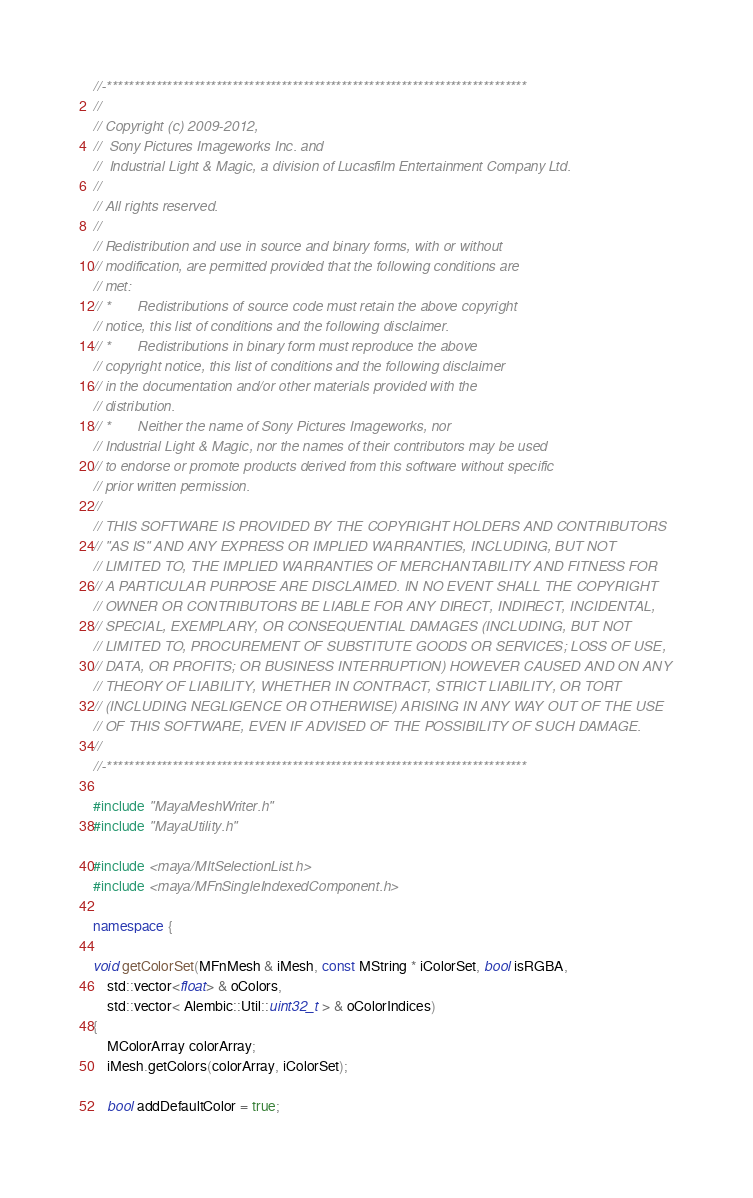Convert code to text. <code><loc_0><loc_0><loc_500><loc_500><_C++_>//-*****************************************************************************
//
// Copyright (c) 2009-2012,
//  Sony Pictures Imageworks Inc. and
//  Industrial Light & Magic, a division of Lucasfilm Entertainment Company Ltd.
//
// All rights reserved.
//
// Redistribution and use in source and binary forms, with or without
// modification, are permitted provided that the following conditions are
// met:
// *       Redistributions of source code must retain the above copyright
// notice, this list of conditions and the following disclaimer.
// *       Redistributions in binary form must reproduce the above
// copyright notice, this list of conditions and the following disclaimer
// in the documentation and/or other materials provided with the
// distribution.
// *       Neither the name of Sony Pictures Imageworks, nor
// Industrial Light & Magic, nor the names of their contributors may be used
// to endorse or promote products derived from this software without specific
// prior written permission.
//
// THIS SOFTWARE IS PROVIDED BY THE COPYRIGHT HOLDERS AND CONTRIBUTORS
// "AS IS" AND ANY EXPRESS OR IMPLIED WARRANTIES, INCLUDING, BUT NOT
// LIMITED TO, THE IMPLIED WARRANTIES OF MERCHANTABILITY AND FITNESS FOR
// A PARTICULAR PURPOSE ARE DISCLAIMED. IN NO EVENT SHALL THE COPYRIGHT
// OWNER OR CONTRIBUTORS BE LIABLE FOR ANY DIRECT, INDIRECT, INCIDENTAL,
// SPECIAL, EXEMPLARY, OR CONSEQUENTIAL DAMAGES (INCLUDING, BUT NOT
// LIMITED TO, PROCUREMENT OF SUBSTITUTE GOODS OR SERVICES; LOSS OF USE,
// DATA, OR PROFITS; OR BUSINESS INTERRUPTION) HOWEVER CAUSED AND ON ANY
// THEORY OF LIABILITY, WHETHER IN CONTRACT, STRICT LIABILITY, OR TORT
// (INCLUDING NEGLIGENCE OR OTHERWISE) ARISING IN ANY WAY OUT OF THE USE
// OF THIS SOFTWARE, EVEN IF ADVISED OF THE POSSIBILITY OF SUCH DAMAGE.
//
//-*****************************************************************************

#include "MayaMeshWriter.h"
#include "MayaUtility.h"

#include <maya/MItSelectionList.h>
#include <maya/MFnSingleIndexedComponent.h>

namespace {

void getColorSet(MFnMesh & iMesh, const MString * iColorSet, bool isRGBA,
    std::vector<float> & oColors,
    std::vector< Alembic::Util::uint32_t > & oColorIndices)
{
    MColorArray colorArray;
    iMesh.getColors(colorArray, iColorSet);

    bool addDefaultColor = true;
</code> 